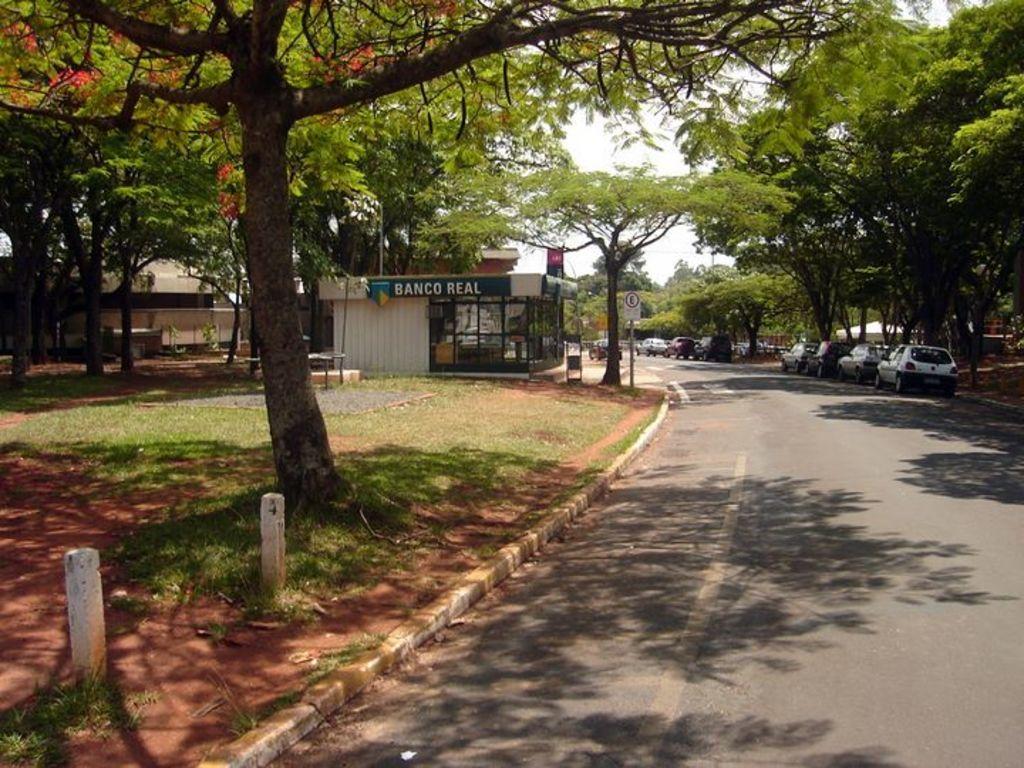Describe this image in one or two sentences. This picture is clicked outside the city. At the bottom of the picture, we see the road. Beside that, we see the soil, grass and cement blocks. On the right side, we see the cars parked on the road. Beside that, we see the trees and a building in white color. In the middle, we see a building and it has the glass windows. Beside that, we see a pole and a board in white color with some text written on it. There are trees and a building in the background. 